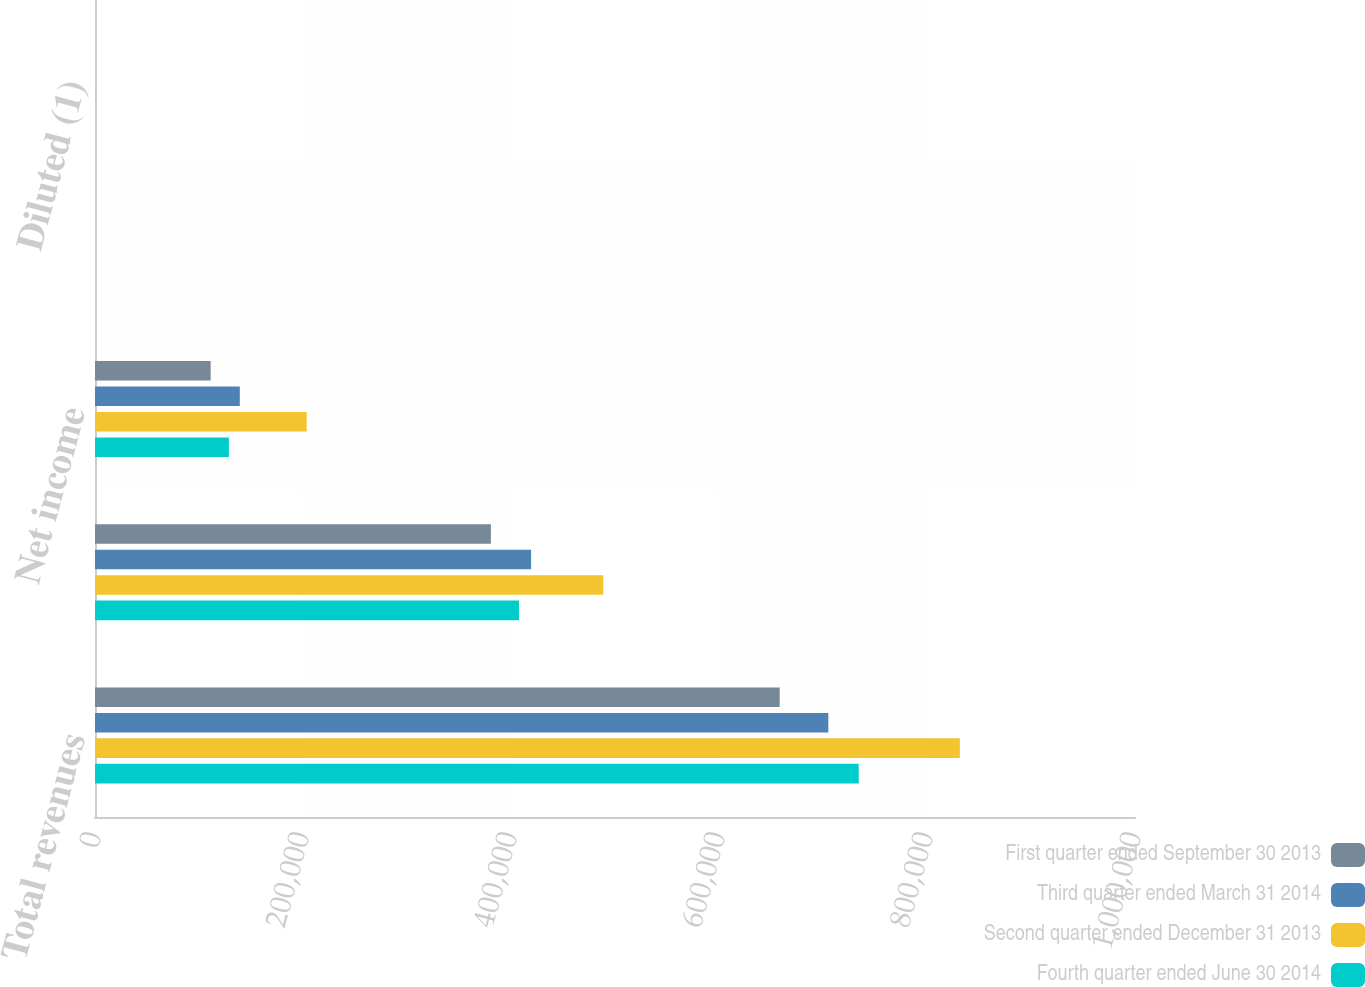Convert chart to OTSL. <chart><loc_0><loc_0><loc_500><loc_500><stacked_bar_chart><ecel><fcel>Total revenues<fcel>Gross margin<fcel>Net income<fcel>Basic (1)<fcel>Diluted (1)<nl><fcel>First quarter ended September 30 2013<fcel>658337<fcel>380680<fcel>111197<fcel>0.67<fcel>0.66<nl><fcel>Third quarter ended March 31 2014<fcel>705129<fcel>419315<fcel>139246<fcel>0.84<fcel>0.83<nl><fcel>Second quarter ended December 31 2013<fcel>831599<fcel>488773<fcel>203581<fcel>1.22<fcel>1.21<nl><fcel>Fourth quarter ended June 30 2014<fcel>734343<fcel>407678<fcel>128731<fcel>0.78<fcel>0.77<nl></chart> 